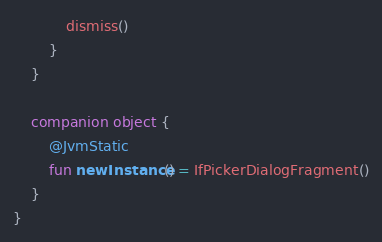<code> <loc_0><loc_0><loc_500><loc_500><_Kotlin_>            dismiss()
        }
    }

    companion object {
        @JvmStatic
        fun newInstance() = IfPickerDialogFragment()
    }
}</code> 